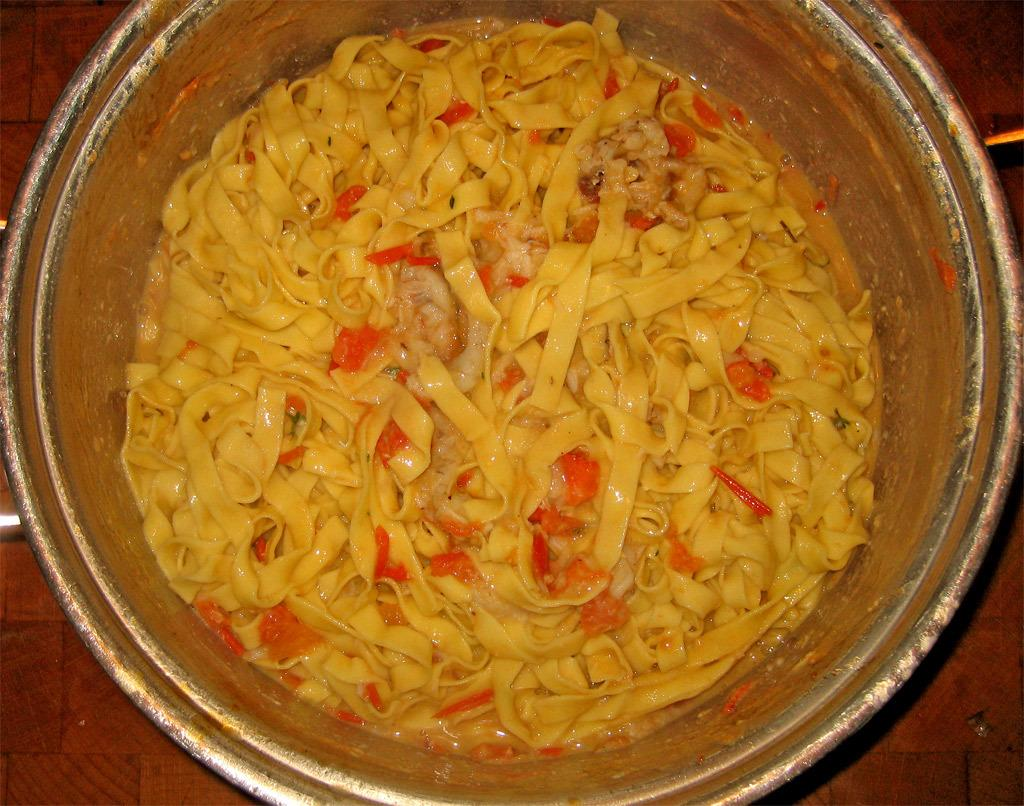What is in the bowl that is visible in the image? There is food in a bowl in the image. What surface is the bowl placed on in the image? There is a floor visible in the image, which suggests that the bowl is placed on the floor. What is the reason for the owner's absence in the image? There is no owner mentioned or visible in the image, so it is not possible to determine the reason for their absence. 